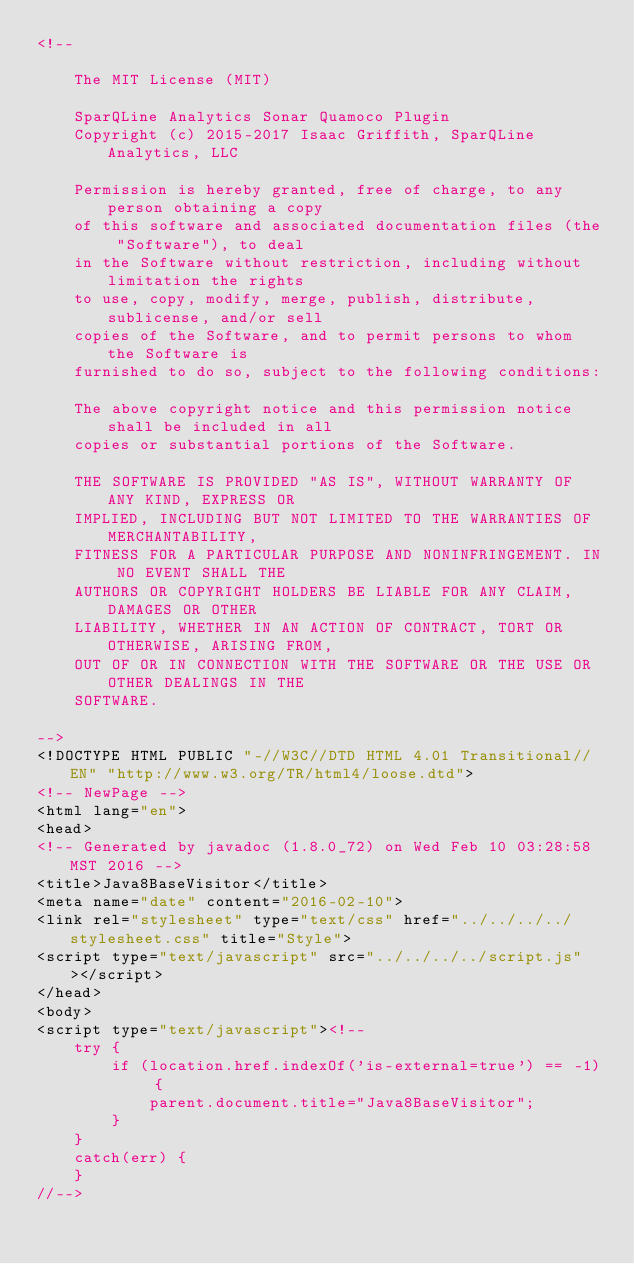<code> <loc_0><loc_0><loc_500><loc_500><_HTML_><!--

    The MIT License (MIT)

    SparQLine Analytics Sonar Quamoco Plugin
    Copyright (c) 2015-2017 Isaac Griffith, SparQLine Analytics, LLC

    Permission is hereby granted, free of charge, to any person obtaining a copy
    of this software and associated documentation files (the "Software"), to deal
    in the Software without restriction, including without limitation the rights
    to use, copy, modify, merge, publish, distribute, sublicense, and/or sell
    copies of the Software, and to permit persons to whom the Software is
    furnished to do so, subject to the following conditions:

    The above copyright notice and this permission notice shall be included in all
    copies or substantial portions of the Software.

    THE SOFTWARE IS PROVIDED "AS IS", WITHOUT WARRANTY OF ANY KIND, EXPRESS OR
    IMPLIED, INCLUDING BUT NOT LIMITED TO THE WARRANTIES OF MERCHANTABILITY,
    FITNESS FOR A PARTICULAR PURPOSE AND NONINFRINGEMENT. IN NO EVENT SHALL THE
    AUTHORS OR COPYRIGHT HOLDERS BE LIABLE FOR ANY CLAIM, DAMAGES OR OTHER
    LIABILITY, WHETHER IN AN ACTION OF CONTRACT, TORT OR OTHERWISE, ARISING FROM,
    OUT OF OR IN CONNECTION WITH THE SOFTWARE OR THE USE OR OTHER DEALINGS IN THE
    SOFTWARE.

-->
<!DOCTYPE HTML PUBLIC "-//W3C//DTD HTML 4.01 Transitional//EN" "http://www.w3.org/TR/html4/loose.dtd">
<!-- NewPage -->
<html lang="en">
<head>
<!-- Generated by javadoc (1.8.0_72) on Wed Feb 10 03:28:58 MST 2016 -->
<title>Java8BaseVisitor</title>
<meta name="date" content="2016-02-10">
<link rel="stylesheet" type="text/css" href="../../../../stylesheet.css" title="Style">
<script type="text/javascript" src="../../../../script.js"></script>
</head>
<body>
<script type="text/javascript"><!--
    try {
        if (location.href.indexOf('is-external=true') == -1) {
            parent.document.title="Java8BaseVisitor";
        }
    }
    catch(err) {
    }
//--></code> 